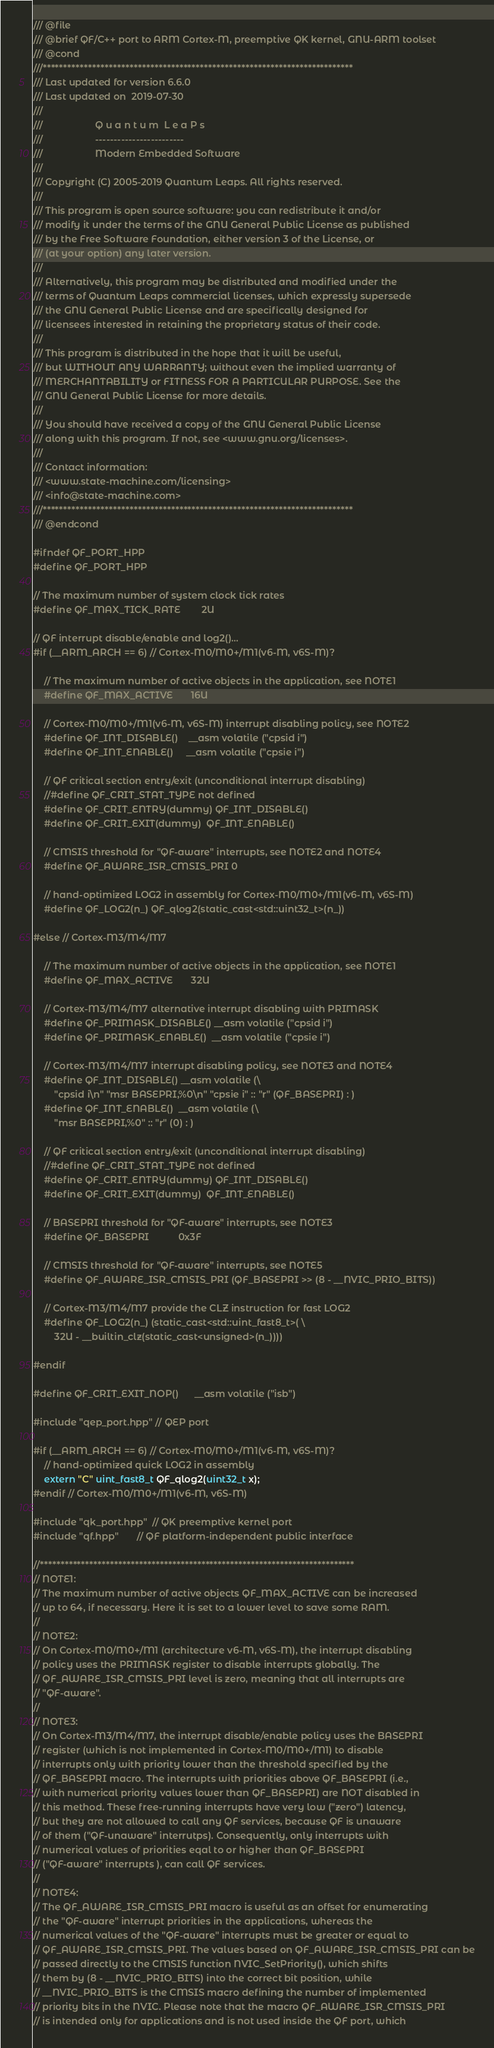<code> <loc_0><loc_0><loc_500><loc_500><_C++_>/// @file
/// @brief QF/C++ port to ARM Cortex-M, preemptive QK kernel, GNU-ARM toolset
/// @cond
///***************************************************************************
/// Last updated for version 6.6.0
/// Last updated on  2019-07-30
///
///                    Q u a n t u m  L e a P s
///                    ------------------------
///                    Modern Embedded Software
///
/// Copyright (C) 2005-2019 Quantum Leaps. All rights reserved.
///
/// This program is open source software: you can redistribute it and/or
/// modify it under the terms of the GNU General Public License as published
/// by the Free Software Foundation, either version 3 of the License, or
/// (at your option) any later version.
///
/// Alternatively, this program may be distributed and modified under the
/// terms of Quantum Leaps commercial licenses, which expressly supersede
/// the GNU General Public License and are specifically designed for
/// licensees interested in retaining the proprietary status of their code.
///
/// This program is distributed in the hope that it will be useful,
/// but WITHOUT ANY WARRANTY; without even the implied warranty of
/// MERCHANTABILITY or FITNESS FOR A PARTICULAR PURPOSE. See the
/// GNU General Public License for more details.
///
/// You should have received a copy of the GNU General Public License
/// along with this program. If not, see <www.gnu.org/licenses>.
///
/// Contact information:
/// <www.state-machine.com/licensing>
/// <info@state-machine.com>
///***************************************************************************
/// @endcond

#ifndef QF_PORT_HPP
#define QF_PORT_HPP

// The maximum number of system clock tick rates
#define QF_MAX_TICK_RATE        2U

// QF interrupt disable/enable and log2()...
#if (__ARM_ARCH == 6) // Cortex-M0/M0+/M1(v6-M, v6S-M)?

    // The maximum number of active objects in the application, see NOTE1
    #define QF_MAX_ACTIVE       16U

    // Cortex-M0/M0+/M1(v6-M, v6S-M) interrupt disabling policy, see NOTE2
    #define QF_INT_DISABLE()    __asm volatile ("cpsid i")
    #define QF_INT_ENABLE()     __asm volatile ("cpsie i")

    // QF critical section entry/exit (unconditional interrupt disabling)
    //#define QF_CRIT_STAT_TYPE not defined
    #define QF_CRIT_ENTRY(dummy) QF_INT_DISABLE()
    #define QF_CRIT_EXIT(dummy)  QF_INT_ENABLE()

    // CMSIS threshold for "QF-aware" interrupts, see NOTE2 and NOTE4
    #define QF_AWARE_ISR_CMSIS_PRI 0

    // hand-optimized LOG2 in assembly for Cortex-M0/M0+/M1(v6-M, v6S-M)
    #define QF_LOG2(n_) QF_qlog2(static_cast<std::uint32_t>(n_))

#else // Cortex-M3/M4/M7

    // The maximum number of active objects in the application, see NOTE1
    #define QF_MAX_ACTIVE       32U

    // Cortex-M3/M4/M7 alternative interrupt disabling with PRIMASK
    #define QF_PRIMASK_DISABLE() __asm volatile ("cpsid i")
    #define QF_PRIMASK_ENABLE()  __asm volatile ("cpsie i")

    // Cortex-M3/M4/M7 interrupt disabling policy, see NOTE3 and NOTE4
    #define QF_INT_DISABLE() __asm volatile (\
        "cpsid i\n" "msr BASEPRI,%0\n" "cpsie i" :: "r" (QF_BASEPRI) : )
    #define QF_INT_ENABLE()  __asm volatile (\
        "msr BASEPRI,%0" :: "r" (0) : )

    // QF critical section entry/exit (unconditional interrupt disabling)
    //#define QF_CRIT_STAT_TYPE not defined
    #define QF_CRIT_ENTRY(dummy) QF_INT_DISABLE()
    #define QF_CRIT_EXIT(dummy)  QF_INT_ENABLE()

    // BASEPRI threshold for "QF-aware" interrupts, see NOTE3
    #define QF_BASEPRI           0x3F

    // CMSIS threshold for "QF-aware" interrupts, see NOTE5
    #define QF_AWARE_ISR_CMSIS_PRI (QF_BASEPRI >> (8 - __NVIC_PRIO_BITS))

    // Cortex-M3/M4/M7 provide the CLZ instruction for fast LOG2
    #define QF_LOG2(n_) (static_cast<std::uint_fast8_t>( \
        32U - __builtin_clz(static_cast<unsigned>(n_))))

#endif

#define QF_CRIT_EXIT_NOP()      __asm volatile ("isb")

#include "qep_port.hpp" // QEP port

#if (__ARM_ARCH == 6) // Cortex-M0/M0+/M1(v6-M, v6S-M)?
    // hand-optimized quick LOG2 in assembly
    extern "C" uint_fast8_t QF_qlog2(uint32_t x);
#endif // Cortex-M0/M0+/M1(v6-M, v6S-M)

#include "qk_port.hpp"  // QK preemptive kernel port
#include "qf.hpp"       // QF platform-independent public interface

//****************************************************************************
// NOTE1:
// The maximum number of active objects QF_MAX_ACTIVE can be increased
// up to 64, if necessary. Here it is set to a lower level to save some RAM.
//
// NOTE2:
// On Cortex-M0/M0+/M1 (architecture v6-M, v6S-M), the interrupt disabling
// policy uses the PRIMASK register to disable interrupts globally. The
// QF_AWARE_ISR_CMSIS_PRI level is zero, meaning that all interrupts are
// "QF-aware".
//
// NOTE3:
// On Cortex-M3/M4/M7, the interrupt disable/enable policy uses the BASEPRI
// register (which is not implemented in Cortex-M0/M0+/M1) to disable
// interrupts only with priority lower than the threshold specified by the
// QF_BASEPRI macro. The interrupts with priorities above QF_BASEPRI (i.e.,
// with numerical priority values lower than QF_BASEPRI) are NOT disabled in
// this method. These free-running interrupts have very low ("zero") latency,
// but they are not allowed to call any QF services, because QF is unaware
// of them ("QF-unaware" interrutps). Consequently, only interrupts with
// numerical values of priorities eqal to or higher than QF_BASEPRI
// ("QF-aware" interrupts ), can call QF services.
//
// NOTE4:
// The QF_AWARE_ISR_CMSIS_PRI macro is useful as an offset for enumerating
// the "QF-aware" interrupt priorities in the applications, whereas the
// numerical values of the "QF-aware" interrupts must be greater or equal to
// QF_AWARE_ISR_CMSIS_PRI. The values based on QF_AWARE_ISR_CMSIS_PRI can be
// passed directly to the CMSIS function NVIC_SetPriority(), which shifts
// them by (8 - __NVIC_PRIO_BITS) into the correct bit position, while
// __NVIC_PRIO_BITS is the CMSIS macro defining the number of implemented
// priority bits in the NVIC. Please note that the macro QF_AWARE_ISR_CMSIS_PRI
// is intended only for applications and is not used inside the QF port, which</code> 